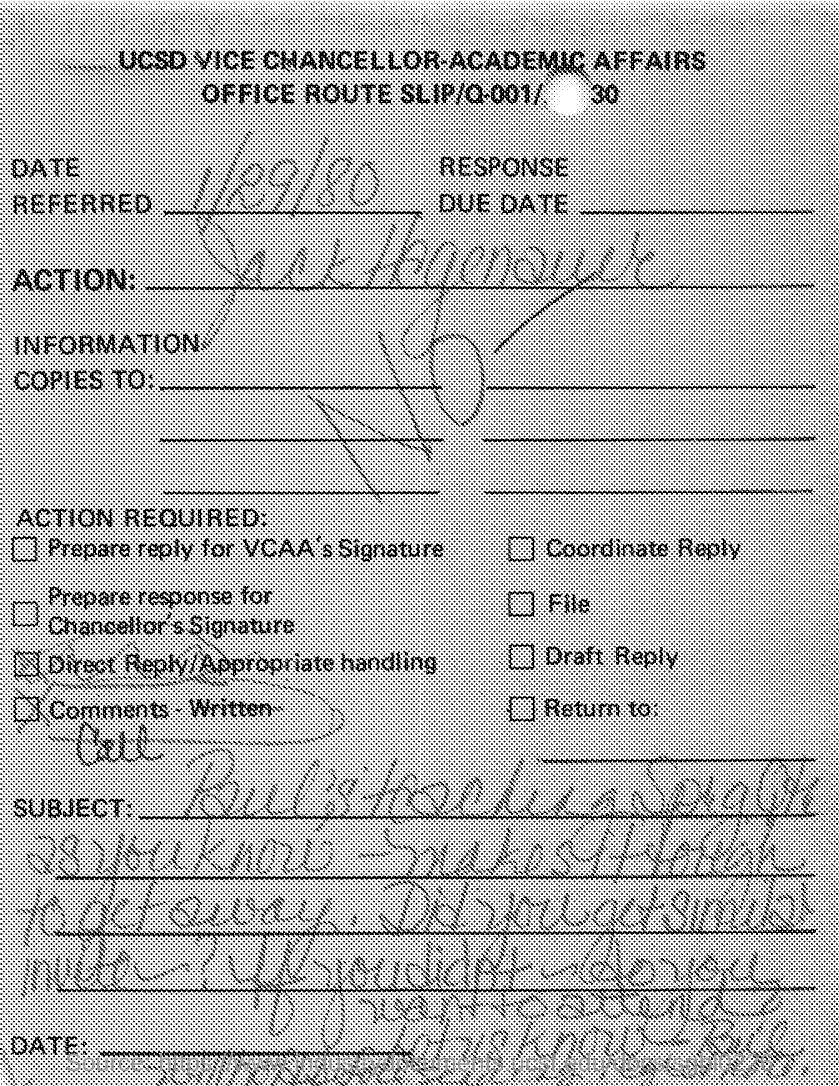What is the Date Referred as per the document?
Your response must be concise. 1/29/80. 